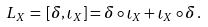Convert formula to latex. <formula><loc_0><loc_0><loc_500><loc_500>L _ { X } \, = \, [ \delta , \iota _ { X } ] = \delta \circ \iota _ { X } + \iota _ { X } \circ \delta \, .</formula> 